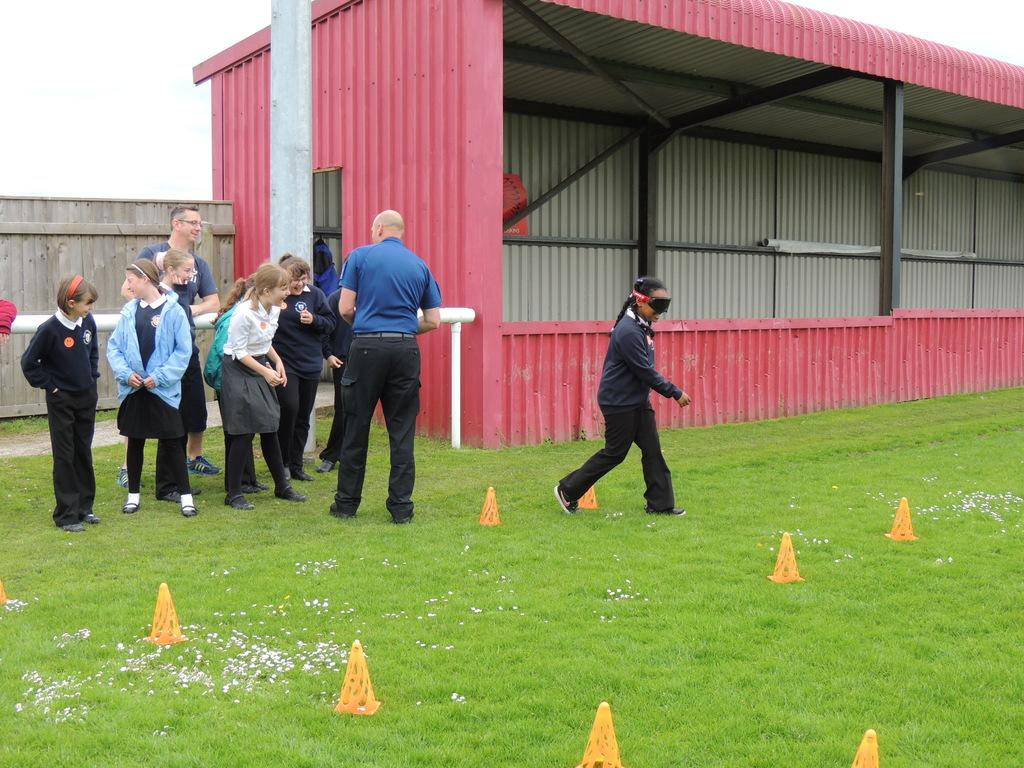What type of structure is visible in the image? There is a shed in the image. What material is used for the wall in the image? There is a wooden wall in the image. What feature can be seen near the shed? There is a railing in the image. What are the people in the image doing? The people appear to be playing a game. What type of surface is visible in the image? There is green grass in the image. How does the school compare to the shed in the image? There is no school present in the image, so it cannot be compared to the shed. What type of seat is visible in the image? There is no seat visible in the image. 